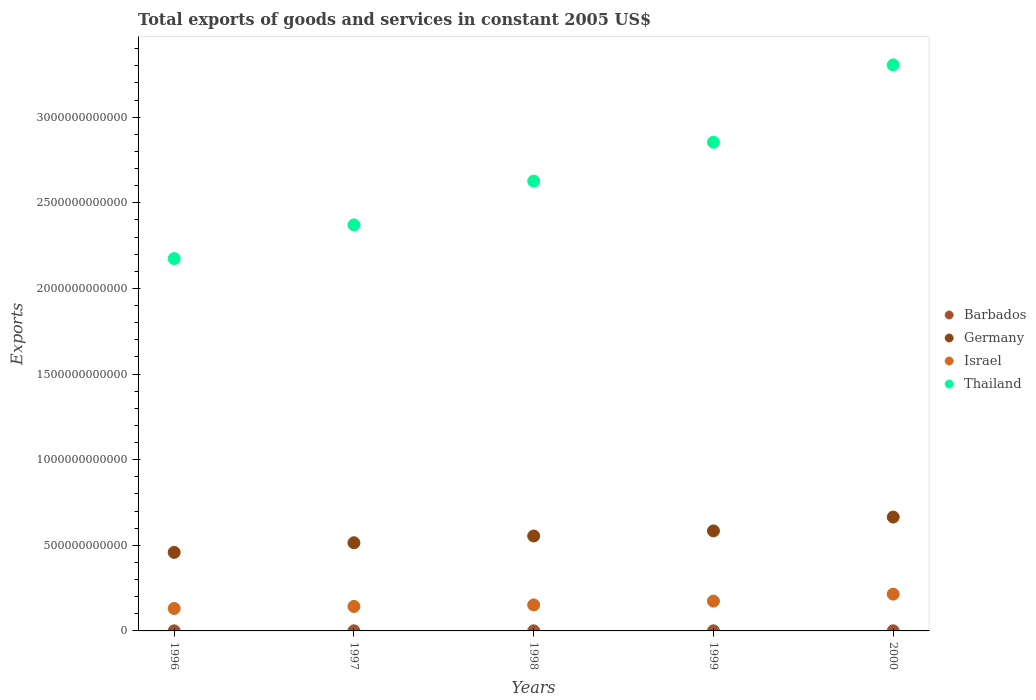How many different coloured dotlines are there?
Your response must be concise. 4. What is the total exports of goods and services in Israel in 1998?
Give a very brief answer. 1.52e+11. Across all years, what is the maximum total exports of goods and services in Thailand?
Offer a terse response. 3.31e+12. Across all years, what is the minimum total exports of goods and services in Thailand?
Ensure brevity in your answer.  2.17e+12. In which year was the total exports of goods and services in Barbados minimum?
Provide a short and direct response. 1996. What is the total total exports of goods and services in Barbados in the graph?
Offer a terse response. 2.96e+09. What is the difference between the total exports of goods and services in Thailand in 1997 and that in 1998?
Keep it short and to the point. -2.56e+11. What is the difference between the total exports of goods and services in Barbados in 1997 and the total exports of goods and services in Thailand in 2000?
Keep it short and to the point. -3.30e+12. What is the average total exports of goods and services in Israel per year?
Your answer should be compact. 1.63e+11. In the year 1996, what is the difference between the total exports of goods and services in Israel and total exports of goods and services in Barbados?
Your answer should be compact. 1.30e+11. In how many years, is the total exports of goods and services in Israel greater than 3200000000000 US$?
Give a very brief answer. 0. What is the ratio of the total exports of goods and services in Barbados in 1997 to that in 1998?
Offer a terse response. 0.93. Is the total exports of goods and services in Barbados in 1997 less than that in 1998?
Keep it short and to the point. Yes. What is the difference between the highest and the second highest total exports of goods and services in Israel?
Keep it short and to the point. 4.07e+1. What is the difference between the highest and the lowest total exports of goods and services in Barbados?
Your response must be concise. 2.19e+08. Is the sum of the total exports of goods and services in Israel in 1997 and 1998 greater than the maximum total exports of goods and services in Thailand across all years?
Make the answer very short. No. Is the total exports of goods and services in Thailand strictly greater than the total exports of goods and services in Barbados over the years?
Provide a short and direct response. Yes. How many dotlines are there?
Keep it short and to the point. 4. What is the difference between two consecutive major ticks on the Y-axis?
Offer a terse response. 5.00e+11. Does the graph contain grids?
Give a very brief answer. No. How many legend labels are there?
Offer a very short reply. 4. What is the title of the graph?
Offer a very short reply. Total exports of goods and services in constant 2005 US$. What is the label or title of the Y-axis?
Offer a very short reply. Exports. What is the Exports in Barbados in 1996?
Provide a succinct answer. 4.89e+08. What is the Exports in Germany in 1996?
Offer a very short reply. 4.58e+11. What is the Exports in Israel in 1996?
Give a very brief answer. 1.31e+11. What is the Exports of Thailand in 1996?
Your answer should be compact. 2.17e+12. What is the Exports of Barbados in 1997?
Offer a very short reply. 5.45e+08. What is the Exports of Germany in 1997?
Your answer should be very brief. 5.15e+11. What is the Exports in Israel in 1997?
Provide a succinct answer. 1.43e+11. What is the Exports in Thailand in 1997?
Provide a succinct answer. 2.37e+12. What is the Exports of Barbados in 1998?
Provide a short and direct response. 5.89e+08. What is the Exports in Germany in 1998?
Offer a very short reply. 5.54e+11. What is the Exports of Israel in 1998?
Give a very brief answer. 1.52e+11. What is the Exports of Thailand in 1998?
Ensure brevity in your answer.  2.63e+12. What is the Exports of Barbados in 1999?
Give a very brief answer. 6.32e+08. What is the Exports in Germany in 1999?
Make the answer very short. 5.84e+11. What is the Exports in Israel in 1999?
Give a very brief answer. 1.74e+11. What is the Exports in Thailand in 1999?
Your response must be concise. 2.85e+12. What is the Exports of Barbados in 2000?
Make the answer very short. 7.08e+08. What is the Exports in Germany in 2000?
Offer a terse response. 6.65e+11. What is the Exports in Israel in 2000?
Give a very brief answer. 2.15e+11. What is the Exports in Thailand in 2000?
Your answer should be compact. 3.31e+12. Across all years, what is the maximum Exports in Barbados?
Your answer should be compact. 7.08e+08. Across all years, what is the maximum Exports in Germany?
Your answer should be very brief. 6.65e+11. Across all years, what is the maximum Exports in Israel?
Offer a very short reply. 2.15e+11. Across all years, what is the maximum Exports of Thailand?
Provide a succinct answer. 3.31e+12. Across all years, what is the minimum Exports of Barbados?
Provide a short and direct response. 4.89e+08. Across all years, what is the minimum Exports of Germany?
Your response must be concise. 4.58e+11. Across all years, what is the minimum Exports of Israel?
Keep it short and to the point. 1.31e+11. Across all years, what is the minimum Exports of Thailand?
Provide a succinct answer. 2.17e+12. What is the total Exports of Barbados in the graph?
Offer a very short reply. 2.96e+09. What is the total Exports of Germany in the graph?
Provide a short and direct response. 2.78e+12. What is the total Exports of Israel in the graph?
Make the answer very short. 8.14e+11. What is the total Exports in Thailand in the graph?
Keep it short and to the point. 1.33e+13. What is the difference between the Exports of Barbados in 1996 and that in 1997?
Offer a terse response. -5.60e+07. What is the difference between the Exports of Germany in 1996 and that in 1997?
Make the answer very short. -5.62e+1. What is the difference between the Exports in Israel in 1996 and that in 1997?
Make the answer very short. -1.20e+1. What is the difference between the Exports in Thailand in 1996 and that in 1997?
Offer a terse response. -1.97e+11. What is the difference between the Exports in Barbados in 1996 and that in 1998?
Your response must be concise. -1.00e+08. What is the difference between the Exports of Germany in 1996 and that in 1998?
Your answer should be very brief. -9.58e+1. What is the difference between the Exports in Israel in 1996 and that in 1998?
Ensure brevity in your answer.  -2.09e+1. What is the difference between the Exports in Thailand in 1996 and that in 1998?
Ensure brevity in your answer.  -4.53e+11. What is the difference between the Exports of Barbados in 1996 and that in 1999?
Your answer should be very brief. -1.43e+08. What is the difference between the Exports of Germany in 1996 and that in 1999?
Provide a short and direct response. -1.25e+11. What is the difference between the Exports of Israel in 1996 and that in 1999?
Give a very brief answer. -4.31e+1. What is the difference between the Exports of Thailand in 1996 and that in 1999?
Your answer should be very brief. -6.79e+11. What is the difference between the Exports of Barbados in 1996 and that in 2000?
Your answer should be compact. -2.19e+08. What is the difference between the Exports of Germany in 1996 and that in 2000?
Make the answer very short. -2.06e+11. What is the difference between the Exports in Israel in 1996 and that in 2000?
Make the answer very short. -8.37e+1. What is the difference between the Exports in Thailand in 1996 and that in 2000?
Offer a very short reply. -1.13e+12. What is the difference between the Exports of Barbados in 1997 and that in 1998?
Give a very brief answer. -4.40e+07. What is the difference between the Exports of Germany in 1997 and that in 1998?
Give a very brief answer. -3.96e+1. What is the difference between the Exports in Israel in 1997 and that in 1998?
Provide a succinct answer. -8.92e+09. What is the difference between the Exports of Thailand in 1997 and that in 1998?
Give a very brief answer. -2.56e+11. What is the difference between the Exports in Barbados in 1997 and that in 1999?
Offer a very short reply. -8.70e+07. What is the difference between the Exports of Germany in 1997 and that in 1999?
Keep it short and to the point. -6.92e+1. What is the difference between the Exports in Israel in 1997 and that in 1999?
Keep it short and to the point. -3.11e+1. What is the difference between the Exports in Thailand in 1997 and that in 1999?
Your answer should be compact. -4.83e+11. What is the difference between the Exports in Barbados in 1997 and that in 2000?
Your response must be concise. -1.63e+08. What is the difference between the Exports of Germany in 1997 and that in 2000?
Offer a very short reply. -1.50e+11. What is the difference between the Exports in Israel in 1997 and that in 2000?
Make the answer very short. -7.18e+1. What is the difference between the Exports of Thailand in 1997 and that in 2000?
Offer a terse response. -9.34e+11. What is the difference between the Exports of Barbados in 1998 and that in 1999?
Offer a terse response. -4.30e+07. What is the difference between the Exports of Germany in 1998 and that in 1999?
Offer a terse response. -2.97e+1. What is the difference between the Exports of Israel in 1998 and that in 1999?
Make the answer very short. -2.22e+1. What is the difference between the Exports in Thailand in 1998 and that in 1999?
Offer a terse response. -2.27e+11. What is the difference between the Exports in Barbados in 1998 and that in 2000?
Make the answer very short. -1.19e+08. What is the difference between the Exports in Germany in 1998 and that in 2000?
Offer a terse response. -1.10e+11. What is the difference between the Exports of Israel in 1998 and that in 2000?
Ensure brevity in your answer.  -6.28e+1. What is the difference between the Exports in Thailand in 1998 and that in 2000?
Provide a short and direct response. -6.79e+11. What is the difference between the Exports in Barbados in 1999 and that in 2000?
Offer a very short reply. -7.60e+07. What is the difference between the Exports in Germany in 1999 and that in 2000?
Provide a succinct answer. -8.08e+1. What is the difference between the Exports of Israel in 1999 and that in 2000?
Your answer should be very brief. -4.07e+1. What is the difference between the Exports in Thailand in 1999 and that in 2000?
Your response must be concise. -4.52e+11. What is the difference between the Exports of Barbados in 1996 and the Exports of Germany in 1997?
Your response must be concise. -5.14e+11. What is the difference between the Exports of Barbados in 1996 and the Exports of Israel in 1997?
Your answer should be very brief. -1.42e+11. What is the difference between the Exports in Barbados in 1996 and the Exports in Thailand in 1997?
Your answer should be compact. -2.37e+12. What is the difference between the Exports in Germany in 1996 and the Exports in Israel in 1997?
Give a very brief answer. 3.16e+11. What is the difference between the Exports of Germany in 1996 and the Exports of Thailand in 1997?
Provide a succinct answer. -1.91e+12. What is the difference between the Exports of Israel in 1996 and the Exports of Thailand in 1997?
Offer a terse response. -2.24e+12. What is the difference between the Exports in Barbados in 1996 and the Exports in Germany in 1998?
Your answer should be very brief. -5.54e+11. What is the difference between the Exports in Barbados in 1996 and the Exports in Israel in 1998?
Offer a terse response. -1.51e+11. What is the difference between the Exports of Barbados in 1996 and the Exports of Thailand in 1998?
Your answer should be compact. -2.63e+12. What is the difference between the Exports in Germany in 1996 and the Exports in Israel in 1998?
Provide a succinct answer. 3.07e+11. What is the difference between the Exports of Germany in 1996 and the Exports of Thailand in 1998?
Give a very brief answer. -2.17e+12. What is the difference between the Exports in Israel in 1996 and the Exports in Thailand in 1998?
Offer a very short reply. -2.50e+12. What is the difference between the Exports in Barbados in 1996 and the Exports in Germany in 1999?
Your answer should be very brief. -5.83e+11. What is the difference between the Exports in Barbados in 1996 and the Exports in Israel in 1999?
Ensure brevity in your answer.  -1.74e+11. What is the difference between the Exports of Barbados in 1996 and the Exports of Thailand in 1999?
Provide a succinct answer. -2.85e+12. What is the difference between the Exports in Germany in 1996 and the Exports in Israel in 1999?
Your answer should be compact. 2.84e+11. What is the difference between the Exports in Germany in 1996 and the Exports in Thailand in 1999?
Provide a short and direct response. -2.39e+12. What is the difference between the Exports of Israel in 1996 and the Exports of Thailand in 1999?
Your answer should be very brief. -2.72e+12. What is the difference between the Exports of Barbados in 1996 and the Exports of Germany in 2000?
Provide a succinct answer. -6.64e+11. What is the difference between the Exports of Barbados in 1996 and the Exports of Israel in 2000?
Provide a short and direct response. -2.14e+11. What is the difference between the Exports of Barbados in 1996 and the Exports of Thailand in 2000?
Make the answer very short. -3.30e+12. What is the difference between the Exports of Germany in 1996 and the Exports of Israel in 2000?
Your response must be concise. 2.44e+11. What is the difference between the Exports in Germany in 1996 and the Exports in Thailand in 2000?
Offer a terse response. -2.85e+12. What is the difference between the Exports in Israel in 1996 and the Exports in Thailand in 2000?
Offer a terse response. -3.17e+12. What is the difference between the Exports of Barbados in 1997 and the Exports of Germany in 1998?
Your answer should be very brief. -5.54e+11. What is the difference between the Exports in Barbados in 1997 and the Exports in Israel in 1998?
Your response must be concise. -1.51e+11. What is the difference between the Exports of Barbados in 1997 and the Exports of Thailand in 1998?
Make the answer very short. -2.63e+12. What is the difference between the Exports of Germany in 1997 and the Exports of Israel in 1998?
Keep it short and to the point. 3.63e+11. What is the difference between the Exports of Germany in 1997 and the Exports of Thailand in 1998?
Offer a very short reply. -2.11e+12. What is the difference between the Exports of Israel in 1997 and the Exports of Thailand in 1998?
Provide a succinct answer. -2.48e+12. What is the difference between the Exports in Barbados in 1997 and the Exports in Germany in 1999?
Offer a very short reply. -5.83e+11. What is the difference between the Exports in Barbados in 1997 and the Exports in Israel in 1999?
Give a very brief answer. -1.73e+11. What is the difference between the Exports in Barbados in 1997 and the Exports in Thailand in 1999?
Make the answer very short. -2.85e+12. What is the difference between the Exports of Germany in 1997 and the Exports of Israel in 1999?
Make the answer very short. 3.41e+11. What is the difference between the Exports of Germany in 1997 and the Exports of Thailand in 1999?
Make the answer very short. -2.34e+12. What is the difference between the Exports in Israel in 1997 and the Exports in Thailand in 1999?
Keep it short and to the point. -2.71e+12. What is the difference between the Exports of Barbados in 1997 and the Exports of Germany in 2000?
Your response must be concise. -6.64e+11. What is the difference between the Exports of Barbados in 1997 and the Exports of Israel in 2000?
Your answer should be compact. -2.14e+11. What is the difference between the Exports of Barbados in 1997 and the Exports of Thailand in 2000?
Your response must be concise. -3.30e+12. What is the difference between the Exports in Germany in 1997 and the Exports in Israel in 2000?
Offer a terse response. 3.00e+11. What is the difference between the Exports in Germany in 1997 and the Exports in Thailand in 2000?
Your response must be concise. -2.79e+12. What is the difference between the Exports of Israel in 1997 and the Exports of Thailand in 2000?
Your answer should be compact. -3.16e+12. What is the difference between the Exports in Barbados in 1998 and the Exports in Germany in 1999?
Keep it short and to the point. -5.83e+11. What is the difference between the Exports of Barbados in 1998 and the Exports of Israel in 1999?
Your answer should be compact. -1.73e+11. What is the difference between the Exports of Barbados in 1998 and the Exports of Thailand in 1999?
Your response must be concise. -2.85e+12. What is the difference between the Exports in Germany in 1998 and the Exports in Israel in 1999?
Make the answer very short. 3.80e+11. What is the difference between the Exports of Germany in 1998 and the Exports of Thailand in 1999?
Your answer should be compact. -2.30e+12. What is the difference between the Exports of Israel in 1998 and the Exports of Thailand in 1999?
Provide a short and direct response. -2.70e+12. What is the difference between the Exports in Barbados in 1998 and the Exports in Germany in 2000?
Keep it short and to the point. -6.64e+11. What is the difference between the Exports of Barbados in 1998 and the Exports of Israel in 2000?
Offer a terse response. -2.14e+11. What is the difference between the Exports in Barbados in 1998 and the Exports in Thailand in 2000?
Provide a succinct answer. -3.30e+12. What is the difference between the Exports in Germany in 1998 and the Exports in Israel in 2000?
Give a very brief answer. 3.40e+11. What is the difference between the Exports of Germany in 1998 and the Exports of Thailand in 2000?
Make the answer very short. -2.75e+12. What is the difference between the Exports in Israel in 1998 and the Exports in Thailand in 2000?
Offer a very short reply. -3.15e+12. What is the difference between the Exports in Barbados in 1999 and the Exports in Germany in 2000?
Offer a very short reply. -6.64e+11. What is the difference between the Exports of Barbados in 1999 and the Exports of Israel in 2000?
Your response must be concise. -2.14e+11. What is the difference between the Exports of Barbados in 1999 and the Exports of Thailand in 2000?
Keep it short and to the point. -3.30e+12. What is the difference between the Exports in Germany in 1999 and the Exports in Israel in 2000?
Keep it short and to the point. 3.69e+11. What is the difference between the Exports of Germany in 1999 and the Exports of Thailand in 2000?
Ensure brevity in your answer.  -2.72e+12. What is the difference between the Exports in Israel in 1999 and the Exports in Thailand in 2000?
Offer a very short reply. -3.13e+12. What is the average Exports of Barbados per year?
Offer a terse response. 5.93e+08. What is the average Exports in Germany per year?
Your response must be concise. 5.55e+11. What is the average Exports of Israel per year?
Your response must be concise. 1.63e+11. What is the average Exports in Thailand per year?
Give a very brief answer. 2.67e+12. In the year 1996, what is the difference between the Exports in Barbados and Exports in Germany?
Provide a succinct answer. -4.58e+11. In the year 1996, what is the difference between the Exports of Barbados and Exports of Israel?
Offer a terse response. -1.30e+11. In the year 1996, what is the difference between the Exports in Barbados and Exports in Thailand?
Offer a very short reply. -2.17e+12. In the year 1996, what is the difference between the Exports of Germany and Exports of Israel?
Your response must be concise. 3.28e+11. In the year 1996, what is the difference between the Exports in Germany and Exports in Thailand?
Provide a succinct answer. -1.72e+12. In the year 1996, what is the difference between the Exports in Israel and Exports in Thailand?
Offer a very short reply. -2.04e+12. In the year 1997, what is the difference between the Exports of Barbados and Exports of Germany?
Ensure brevity in your answer.  -5.14e+11. In the year 1997, what is the difference between the Exports in Barbados and Exports in Israel?
Your answer should be compact. -1.42e+11. In the year 1997, what is the difference between the Exports in Barbados and Exports in Thailand?
Your answer should be very brief. -2.37e+12. In the year 1997, what is the difference between the Exports in Germany and Exports in Israel?
Keep it short and to the point. 3.72e+11. In the year 1997, what is the difference between the Exports of Germany and Exports of Thailand?
Provide a succinct answer. -1.86e+12. In the year 1997, what is the difference between the Exports of Israel and Exports of Thailand?
Make the answer very short. -2.23e+12. In the year 1998, what is the difference between the Exports in Barbados and Exports in Germany?
Your answer should be compact. -5.54e+11. In the year 1998, what is the difference between the Exports in Barbados and Exports in Israel?
Provide a succinct answer. -1.51e+11. In the year 1998, what is the difference between the Exports of Barbados and Exports of Thailand?
Your answer should be compact. -2.63e+12. In the year 1998, what is the difference between the Exports in Germany and Exports in Israel?
Provide a short and direct response. 4.02e+11. In the year 1998, what is the difference between the Exports in Germany and Exports in Thailand?
Ensure brevity in your answer.  -2.07e+12. In the year 1998, what is the difference between the Exports of Israel and Exports of Thailand?
Make the answer very short. -2.47e+12. In the year 1999, what is the difference between the Exports of Barbados and Exports of Germany?
Ensure brevity in your answer.  -5.83e+11. In the year 1999, what is the difference between the Exports of Barbados and Exports of Israel?
Keep it short and to the point. -1.73e+11. In the year 1999, what is the difference between the Exports of Barbados and Exports of Thailand?
Ensure brevity in your answer.  -2.85e+12. In the year 1999, what is the difference between the Exports in Germany and Exports in Israel?
Give a very brief answer. 4.10e+11. In the year 1999, what is the difference between the Exports in Germany and Exports in Thailand?
Give a very brief answer. -2.27e+12. In the year 1999, what is the difference between the Exports in Israel and Exports in Thailand?
Give a very brief answer. -2.68e+12. In the year 2000, what is the difference between the Exports of Barbados and Exports of Germany?
Your answer should be compact. -6.64e+11. In the year 2000, what is the difference between the Exports in Barbados and Exports in Israel?
Your answer should be very brief. -2.14e+11. In the year 2000, what is the difference between the Exports in Barbados and Exports in Thailand?
Your answer should be very brief. -3.30e+12. In the year 2000, what is the difference between the Exports in Germany and Exports in Israel?
Give a very brief answer. 4.50e+11. In the year 2000, what is the difference between the Exports in Germany and Exports in Thailand?
Keep it short and to the point. -2.64e+12. In the year 2000, what is the difference between the Exports in Israel and Exports in Thailand?
Offer a very short reply. -3.09e+12. What is the ratio of the Exports in Barbados in 1996 to that in 1997?
Ensure brevity in your answer.  0.9. What is the ratio of the Exports of Germany in 1996 to that in 1997?
Give a very brief answer. 0.89. What is the ratio of the Exports of Israel in 1996 to that in 1997?
Your answer should be very brief. 0.92. What is the ratio of the Exports in Thailand in 1996 to that in 1997?
Make the answer very short. 0.92. What is the ratio of the Exports in Barbados in 1996 to that in 1998?
Your answer should be very brief. 0.83. What is the ratio of the Exports in Germany in 1996 to that in 1998?
Provide a succinct answer. 0.83. What is the ratio of the Exports in Israel in 1996 to that in 1998?
Ensure brevity in your answer.  0.86. What is the ratio of the Exports of Thailand in 1996 to that in 1998?
Your response must be concise. 0.83. What is the ratio of the Exports in Barbados in 1996 to that in 1999?
Your response must be concise. 0.77. What is the ratio of the Exports in Germany in 1996 to that in 1999?
Your response must be concise. 0.79. What is the ratio of the Exports in Israel in 1996 to that in 1999?
Your response must be concise. 0.75. What is the ratio of the Exports of Thailand in 1996 to that in 1999?
Give a very brief answer. 0.76. What is the ratio of the Exports in Barbados in 1996 to that in 2000?
Give a very brief answer. 0.69. What is the ratio of the Exports in Germany in 1996 to that in 2000?
Keep it short and to the point. 0.69. What is the ratio of the Exports of Israel in 1996 to that in 2000?
Provide a succinct answer. 0.61. What is the ratio of the Exports in Thailand in 1996 to that in 2000?
Your answer should be very brief. 0.66. What is the ratio of the Exports of Barbados in 1997 to that in 1998?
Your answer should be very brief. 0.93. What is the ratio of the Exports of Germany in 1997 to that in 1998?
Your answer should be very brief. 0.93. What is the ratio of the Exports of Israel in 1997 to that in 1998?
Offer a very short reply. 0.94. What is the ratio of the Exports in Thailand in 1997 to that in 1998?
Provide a succinct answer. 0.9. What is the ratio of the Exports of Barbados in 1997 to that in 1999?
Your answer should be very brief. 0.86. What is the ratio of the Exports of Germany in 1997 to that in 1999?
Your answer should be compact. 0.88. What is the ratio of the Exports of Israel in 1997 to that in 1999?
Provide a succinct answer. 0.82. What is the ratio of the Exports of Thailand in 1997 to that in 1999?
Your response must be concise. 0.83. What is the ratio of the Exports of Barbados in 1997 to that in 2000?
Offer a very short reply. 0.77. What is the ratio of the Exports in Germany in 1997 to that in 2000?
Make the answer very short. 0.77. What is the ratio of the Exports in Israel in 1997 to that in 2000?
Your answer should be very brief. 0.67. What is the ratio of the Exports of Thailand in 1997 to that in 2000?
Make the answer very short. 0.72. What is the ratio of the Exports in Barbados in 1998 to that in 1999?
Give a very brief answer. 0.93. What is the ratio of the Exports in Germany in 1998 to that in 1999?
Give a very brief answer. 0.95. What is the ratio of the Exports of Israel in 1998 to that in 1999?
Make the answer very short. 0.87. What is the ratio of the Exports of Thailand in 1998 to that in 1999?
Your answer should be compact. 0.92. What is the ratio of the Exports of Barbados in 1998 to that in 2000?
Provide a short and direct response. 0.83. What is the ratio of the Exports of Germany in 1998 to that in 2000?
Keep it short and to the point. 0.83. What is the ratio of the Exports of Israel in 1998 to that in 2000?
Keep it short and to the point. 0.71. What is the ratio of the Exports in Thailand in 1998 to that in 2000?
Keep it short and to the point. 0.79. What is the ratio of the Exports in Barbados in 1999 to that in 2000?
Your response must be concise. 0.89. What is the ratio of the Exports in Germany in 1999 to that in 2000?
Your answer should be very brief. 0.88. What is the ratio of the Exports of Israel in 1999 to that in 2000?
Ensure brevity in your answer.  0.81. What is the ratio of the Exports in Thailand in 1999 to that in 2000?
Your answer should be compact. 0.86. What is the difference between the highest and the second highest Exports of Barbados?
Your answer should be compact. 7.60e+07. What is the difference between the highest and the second highest Exports in Germany?
Your response must be concise. 8.08e+1. What is the difference between the highest and the second highest Exports in Israel?
Keep it short and to the point. 4.07e+1. What is the difference between the highest and the second highest Exports in Thailand?
Your answer should be very brief. 4.52e+11. What is the difference between the highest and the lowest Exports in Barbados?
Make the answer very short. 2.19e+08. What is the difference between the highest and the lowest Exports of Germany?
Your answer should be very brief. 2.06e+11. What is the difference between the highest and the lowest Exports of Israel?
Your response must be concise. 8.37e+1. What is the difference between the highest and the lowest Exports in Thailand?
Give a very brief answer. 1.13e+12. 